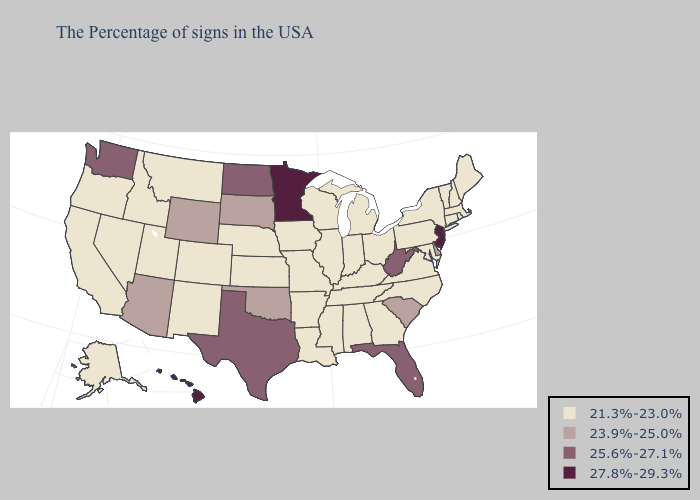What is the highest value in the South ?
Keep it brief. 25.6%-27.1%. Name the states that have a value in the range 23.9%-25.0%?
Short answer required. Delaware, South Carolina, Oklahoma, South Dakota, Wyoming, Arizona. Name the states that have a value in the range 25.6%-27.1%?
Short answer required. West Virginia, Florida, Texas, North Dakota, Washington. Among the states that border Wyoming , does South Dakota have the lowest value?
Answer briefly. No. Among the states that border Mississippi , which have the lowest value?
Write a very short answer. Alabama, Tennessee, Louisiana, Arkansas. What is the highest value in the USA?
Write a very short answer. 27.8%-29.3%. What is the highest value in the MidWest ?
Give a very brief answer. 27.8%-29.3%. What is the value of Washington?
Write a very short answer. 25.6%-27.1%. What is the value of New Jersey?
Keep it brief. 27.8%-29.3%. What is the value of Kansas?
Concise answer only. 21.3%-23.0%. Name the states that have a value in the range 27.8%-29.3%?
Be succinct. New Jersey, Minnesota, Hawaii. Does Nebraska have the highest value in the MidWest?
Give a very brief answer. No. What is the lowest value in states that border Utah?
Keep it brief. 21.3%-23.0%. 